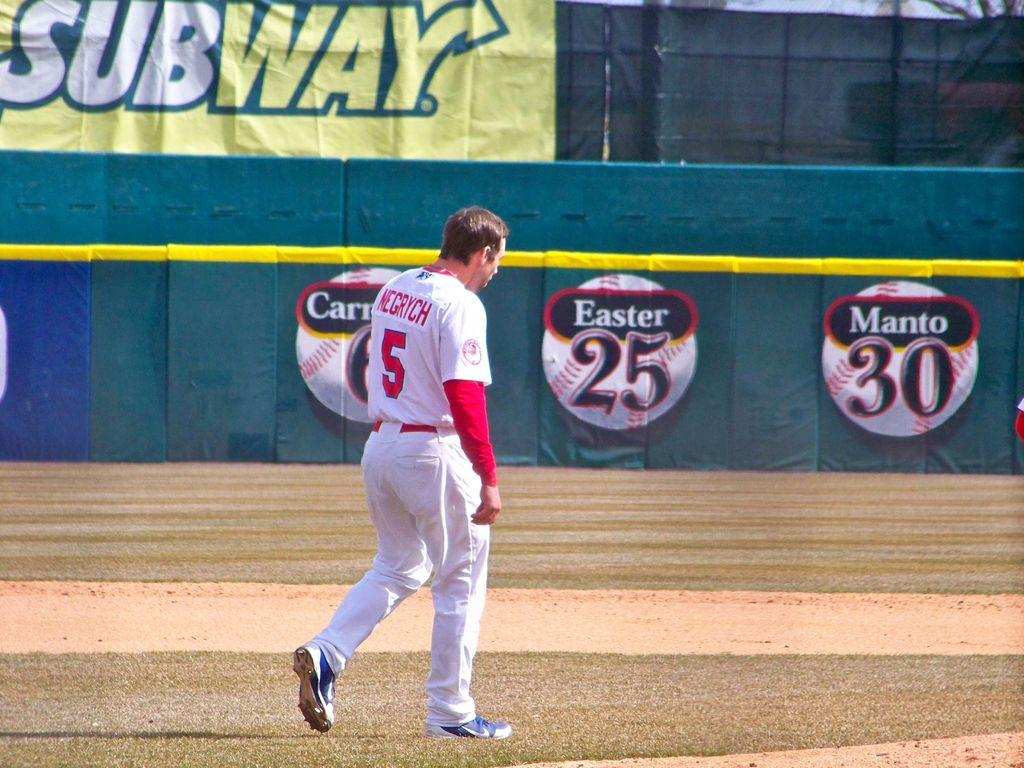Provide a one-sentence caption for the provided image. A man wearing the jersey number 5 with the name Negrych walks in front of an ad for Subway. 